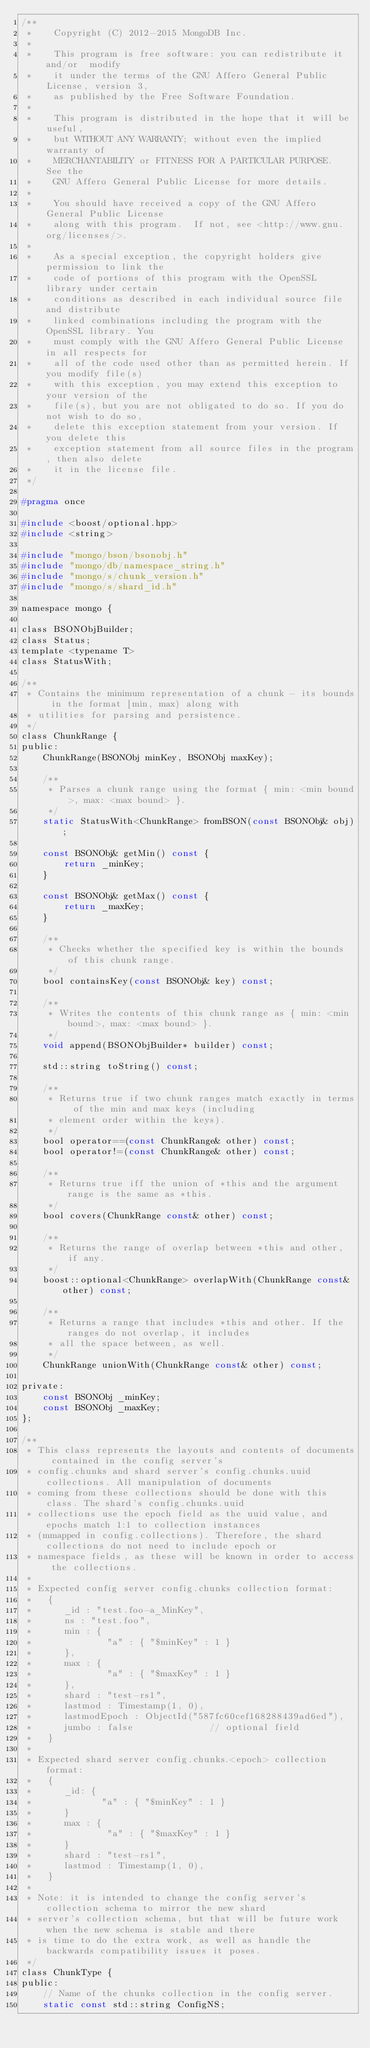Convert code to text. <code><loc_0><loc_0><loc_500><loc_500><_C_>/**
 *    Copyright (C) 2012-2015 MongoDB Inc.
 *
 *    This program is free software: you can redistribute it and/or  modify
 *    it under the terms of the GNU Affero General Public License, version 3,
 *    as published by the Free Software Foundation.
 *
 *    This program is distributed in the hope that it will be useful,
 *    but WITHOUT ANY WARRANTY; without even the implied warranty of
 *    MERCHANTABILITY or FITNESS FOR A PARTICULAR PURPOSE.  See the
 *    GNU Affero General Public License for more details.
 *
 *    You should have received a copy of the GNU Affero General Public License
 *    along with this program.  If not, see <http://www.gnu.org/licenses/>.
 *
 *    As a special exception, the copyright holders give permission to link the
 *    code of portions of this program with the OpenSSL library under certain
 *    conditions as described in each individual source file and distribute
 *    linked combinations including the program with the OpenSSL library. You
 *    must comply with the GNU Affero General Public License in all respects for
 *    all of the code used other than as permitted herein. If you modify file(s)
 *    with this exception, you may extend this exception to your version of the
 *    file(s), but you are not obligated to do so. If you do not wish to do so,
 *    delete this exception statement from your version. If you delete this
 *    exception statement from all source files in the program, then also delete
 *    it in the license file.
 */

#pragma once

#include <boost/optional.hpp>
#include <string>

#include "mongo/bson/bsonobj.h"
#include "mongo/db/namespace_string.h"
#include "mongo/s/chunk_version.h"
#include "mongo/s/shard_id.h"

namespace mongo {

class BSONObjBuilder;
class Status;
template <typename T>
class StatusWith;

/**
 * Contains the minimum representation of a chunk - its bounds in the format [min, max) along with
 * utilities for parsing and persistence.
 */
class ChunkRange {
public:
    ChunkRange(BSONObj minKey, BSONObj maxKey);

    /**
     * Parses a chunk range using the format { min: <min bound>, max: <max bound> }.
     */
    static StatusWith<ChunkRange> fromBSON(const BSONObj& obj);

    const BSONObj& getMin() const {
        return _minKey;
    }

    const BSONObj& getMax() const {
        return _maxKey;
    }

    /**
     * Checks whether the specified key is within the bounds of this chunk range.
     */
    bool containsKey(const BSONObj& key) const;

    /**
     * Writes the contents of this chunk range as { min: <min bound>, max: <max bound> }.
     */
    void append(BSONObjBuilder* builder) const;

    std::string toString() const;

    /**
     * Returns true if two chunk ranges match exactly in terms of the min and max keys (including
     * element order within the keys).
     */
    bool operator==(const ChunkRange& other) const;
    bool operator!=(const ChunkRange& other) const;

    /**
     * Returns true iff the union of *this and the argument range is the same as *this.
     */
    bool covers(ChunkRange const& other) const;

    /**
     * Returns the range of overlap between *this and other, if any.
     */
    boost::optional<ChunkRange> overlapWith(ChunkRange const& other) const;

    /**
     * Returns a range that includes *this and other. If the ranges do not overlap, it includes
     * all the space between, as well.
     */
    ChunkRange unionWith(ChunkRange const& other) const;

private:
    const BSONObj _minKey;
    const BSONObj _maxKey;
};

/**
 * This class represents the layouts and contents of documents contained in the config server's
 * config.chunks and shard server's config.chunks.uuid collections. All manipulation of documents
 * coming from these collections should be done with this class. The shard's config.chunks.uuid
 * collections use the epoch field as the uuid value, and epochs match 1:1 to collection instances
 * (mmapped in config.collections). Therefore, the shard collections do not need to include epoch or
 * namespace fields, as these will be known in order to access the collections.
 *
 * Expected config server config.chunks collection format:
 *   {
 *      _id : "test.foo-a_MinKey",
 *      ns : "test.foo",
 *      min : {
 *              "a" : { "$minKey" : 1 }
 *      },
 *      max : {
 *              "a" : { "$maxKey" : 1 }
 *      },
 *      shard : "test-rs1",
 *      lastmod : Timestamp(1, 0),
 *      lastmodEpoch : ObjectId("587fc60cef168288439ad6ed"),
 *      jumbo : false              // optional field
 *   }
 *
 * Expected shard server config.chunks.<epoch> collection format:
 *   {
 *      _id: {
 *             "a" : { "$minKey" : 1 }
 *      }
 *      max : {
 *              "a" : { "$maxKey" : 1 }
 *      }
 *      shard : "test-rs1",
 *      lastmod : Timestamp(1, 0),
 *   }
 *
 * Note: it is intended to change the config server's collection schema to mirror the new shard
 * server's collection schema, but that will be future work when the new schema is stable and there
 * is time to do the extra work, as well as handle the backwards compatibility issues it poses.
 */
class ChunkType {
public:
    // Name of the chunks collection in the config server.
    static const std::string ConfigNS;
</code> 